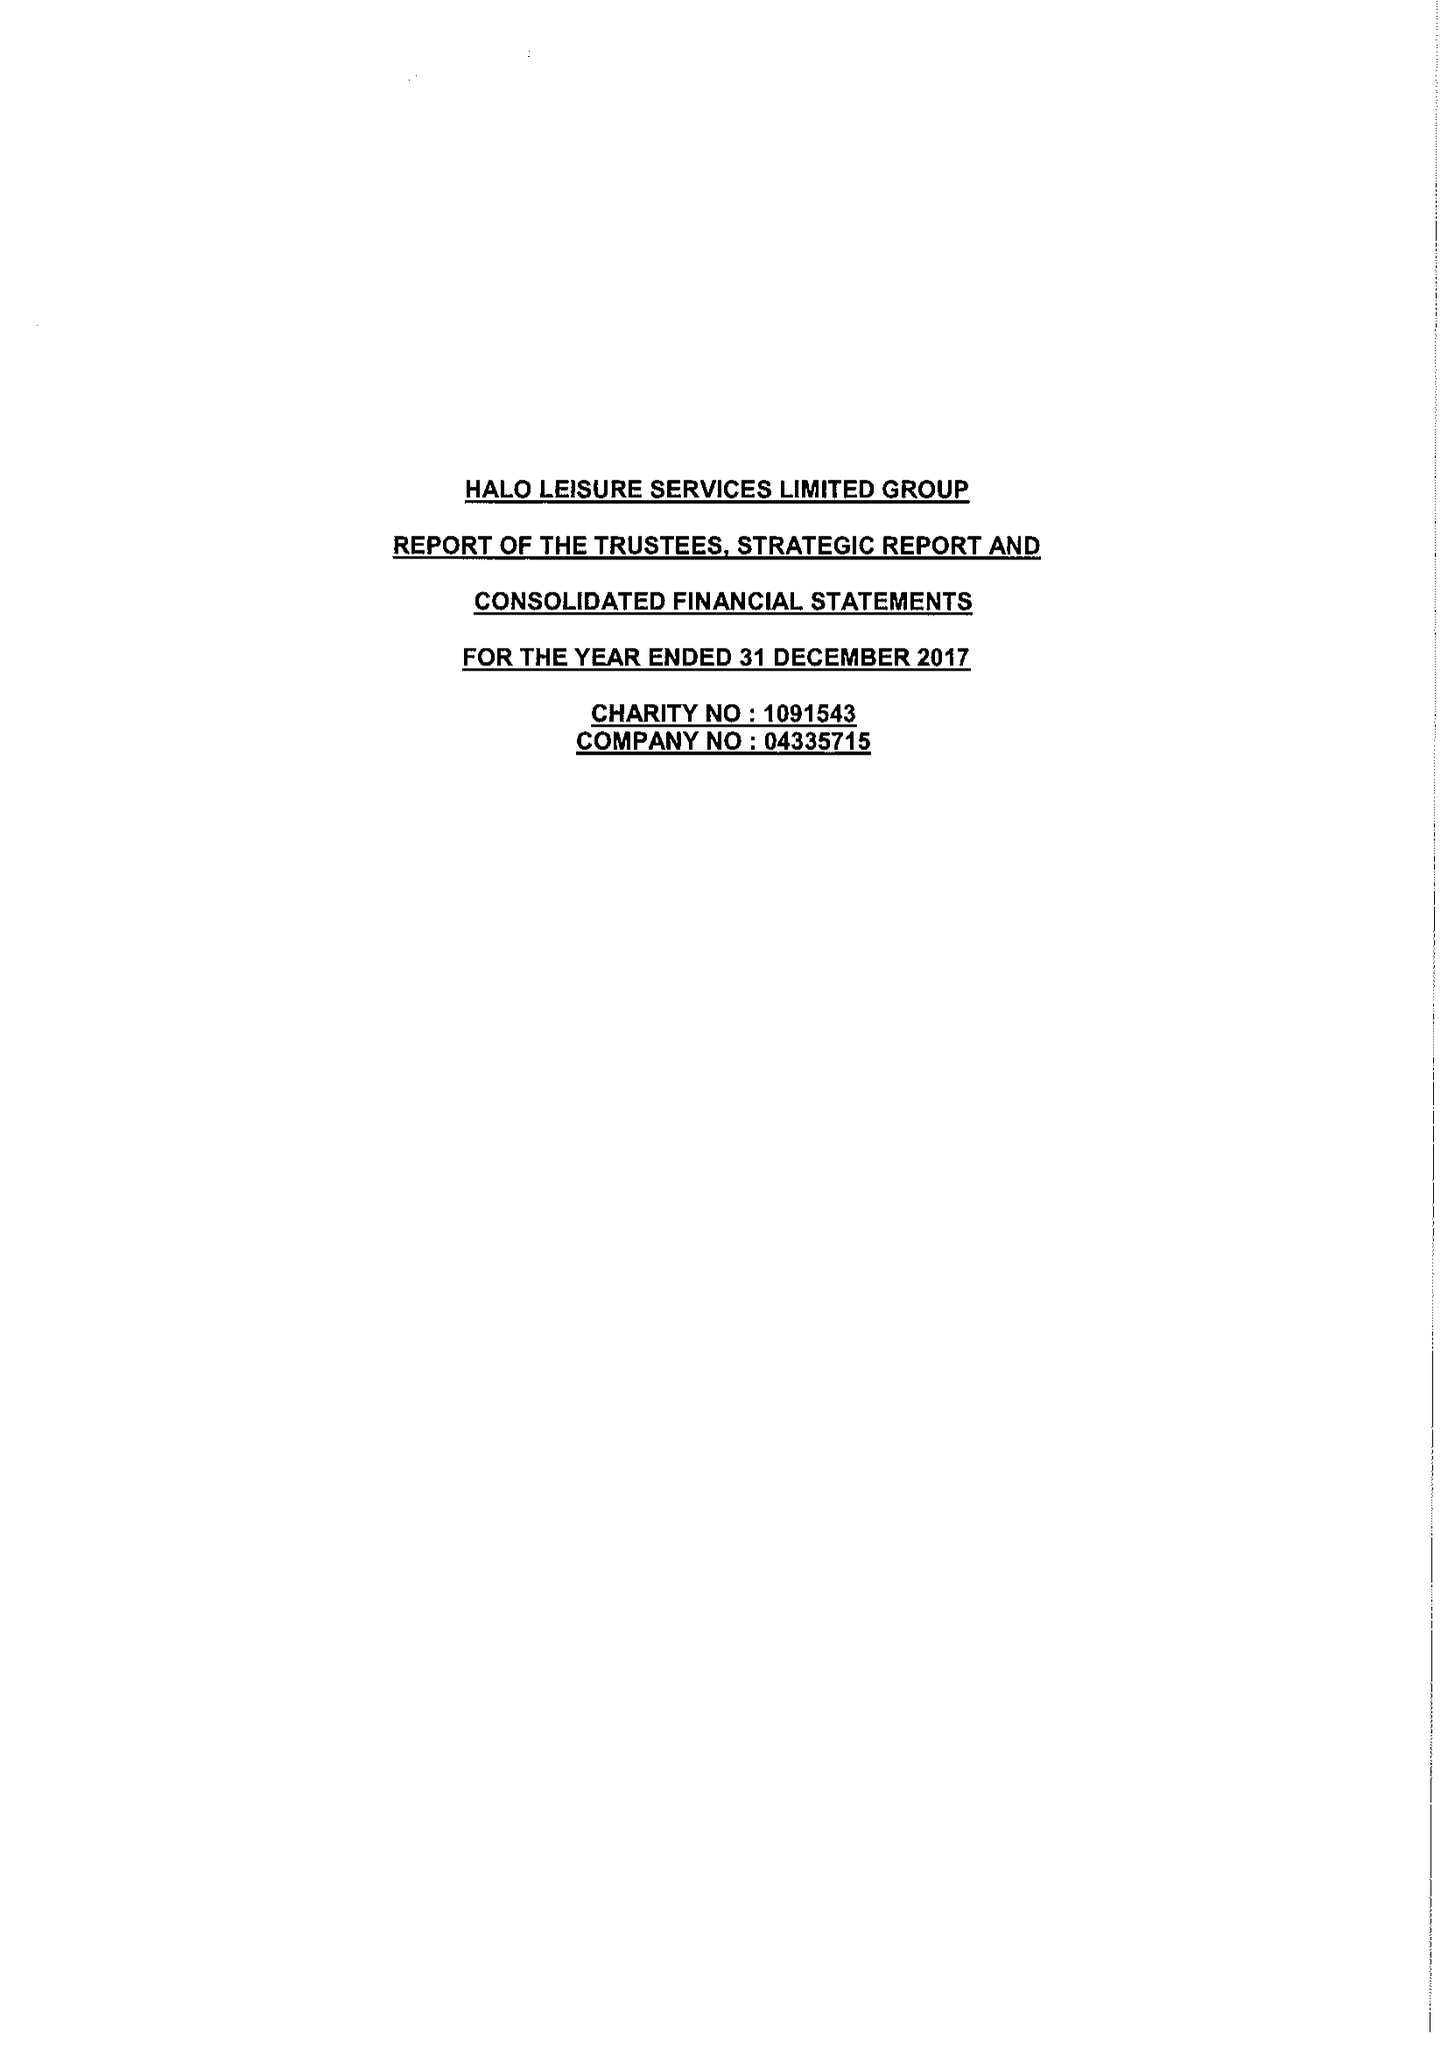What is the value for the income_annually_in_british_pounds?
Answer the question using a single word or phrase. 16476938.00 